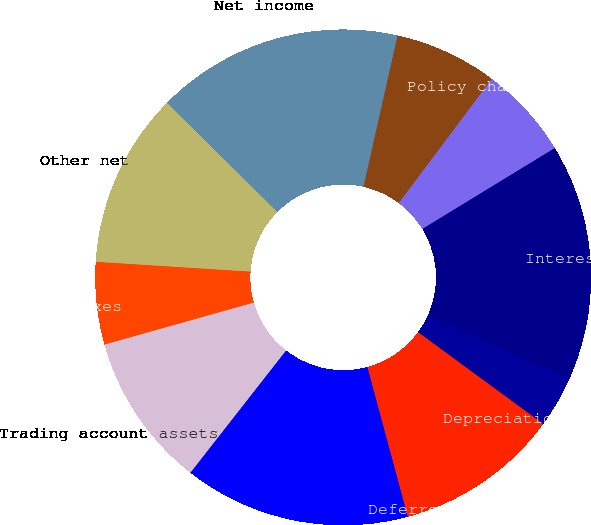Convert chart to OTSL. <chart><loc_0><loc_0><loc_500><loc_500><pie_chart><fcel>Net income<fcel>Realized investment gains net<fcel>Policy charges and fee income<fcel>Interest credited to<fcel>Depreciation and amortization<fcel>Deferred policy acquisition<fcel>Future policy benefits and<fcel>Trading account assets<fcel>Income taxes<fcel>Other net<nl><fcel>16.11%<fcel>6.71%<fcel>6.04%<fcel>15.44%<fcel>3.36%<fcel>10.74%<fcel>14.76%<fcel>10.07%<fcel>5.37%<fcel>11.41%<nl></chart> 